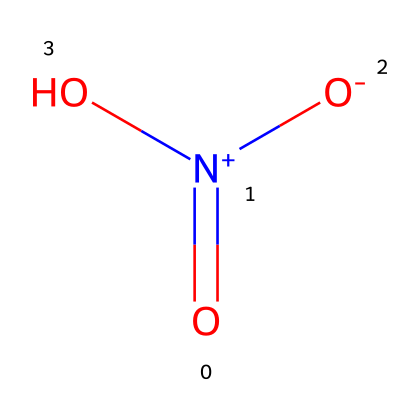What is the molecular formula of this chemical? The chemical structure represented by the SMILES notation corresponds to nitrogen oxides. The breakdown of atoms shows that there are 3 oxygen atoms and 1 nitrogen atom. Therefore, the molecular formula is derived from these counts.
Answer: NO3 How many total atoms are present in this molecule? By examining the SMILES representation, we identify one nitrogen atom and three oxygen atoms, making a total of four atoms overall when combined.
Answer: 4 What type of bonding is present in this chemical? The chemical has multiple bonding types between nitrogen and oxygen, including a coordinate bond and ionically influenced interactions due to oxidation states. This mixture creates a resonance structure typical for nitrogen oxides.
Answer: ionic What is the oxidation state of nitrogen in this molecule? Analyzing the connectivity and charges in the SMILES structure indicates that nitrogen is in a +5 oxidation state, as it is bonded to three oxygen atoms, where one has a negative charge, balancing out the positive charge on nitrogen.
Answer: +5 What is the common name for this chemical? This chemical is commonly known as nitrogen trioxide, which is a straightforward derivation from its molecular structure, highlighting its composition of nitrogen and oxygen.
Answer: nitrogen trioxide Is this gas harmful to human health? Nitrogen oxides, particularly at elevated concentrations in urban areas, are recognized for contributing to respiratory issues and other health problems, demonstrating their harmful nature.
Answer: yes 